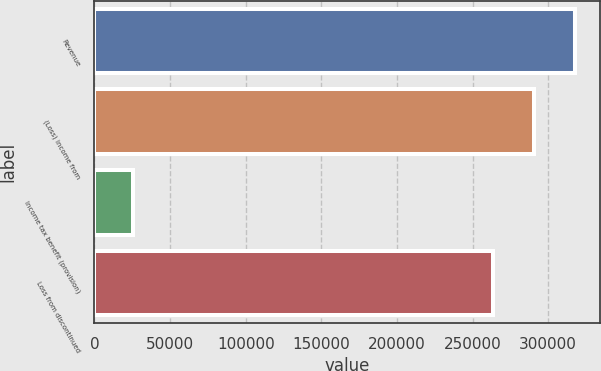<chart> <loc_0><loc_0><loc_500><loc_500><bar_chart><fcel>Revenue<fcel>(Loss) income from<fcel>Income tax benefit (provision)<fcel>Loss from discontinued<nl><fcel>318062<fcel>290744<fcel>25541<fcel>263427<nl></chart> 